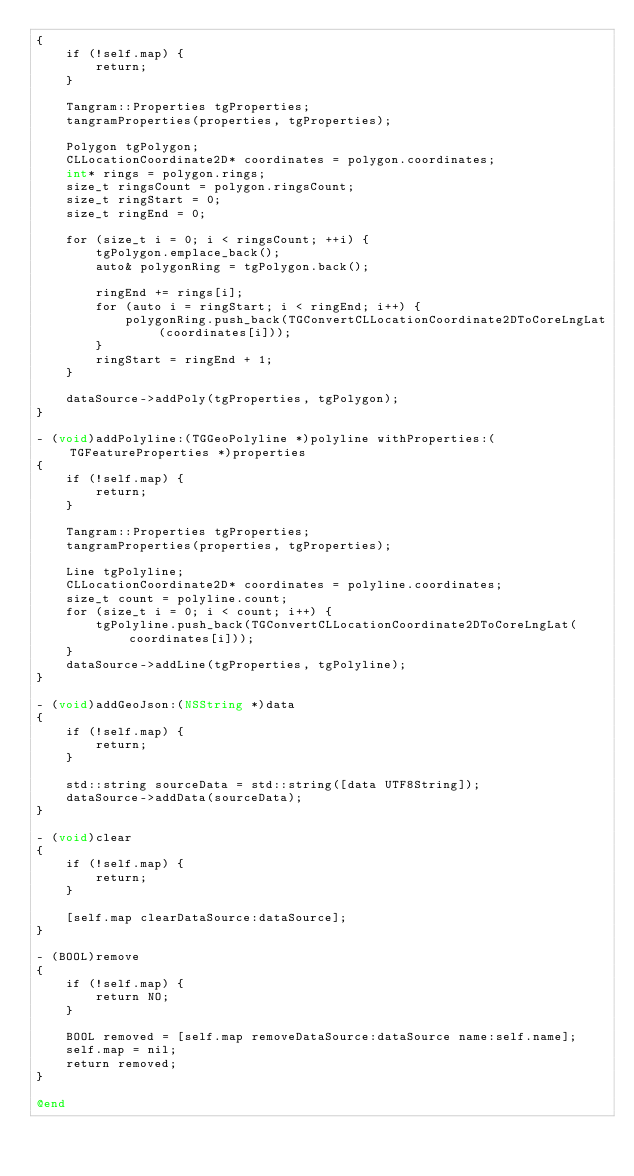<code> <loc_0><loc_0><loc_500><loc_500><_ObjectiveC_>{
    if (!self.map) {
        return;
    }

    Tangram::Properties tgProperties;
    tangramProperties(properties, tgProperties);

    Polygon tgPolygon;
    CLLocationCoordinate2D* coordinates = polygon.coordinates;
    int* rings = polygon.rings;
    size_t ringsCount = polygon.ringsCount;
    size_t ringStart = 0;
    size_t ringEnd = 0;

    for (size_t i = 0; i < ringsCount; ++i) {
        tgPolygon.emplace_back();
        auto& polygonRing = tgPolygon.back();

        ringEnd += rings[i];
        for (auto i = ringStart; i < ringEnd; i++) {
            polygonRing.push_back(TGConvertCLLocationCoordinate2DToCoreLngLat(coordinates[i]));
        }
        ringStart = ringEnd + 1;
    }

    dataSource->addPoly(tgProperties, tgPolygon);
}

- (void)addPolyline:(TGGeoPolyline *)polyline withProperties:(TGFeatureProperties *)properties
{
    if (!self.map) {
        return;
    }

    Tangram::Properties tgProperties;
    tangramProperties(properties, tgProperties);

    Line tgPolyline;
    CLLocationCoordinate2D* coordinates = polyline.coordinates;
    size_t count = polyline.count;
    for (size_t i = 0; i < count; i++) {
        tgPolyline.push_back(TGConvertCLLocationCoordinate2DToCoreLngLat(coordinates[i]));
    }
    dataSource->addLine(tgProperties, tgPolyline);
}

- (void)addGeoJson:(NSString *)data
{
    if (!self.map) {
        return;
    }

    std::string sourceData = std::string([data UTF8String]);
    dataSource->addData(sourceData);
}

- (void)clear
{
    if (!self.map) {
        return;
    }

    [self.map clearDataSource:dataSource];
}

- (BOOL)remove
{
    if (!self.map) {
        return NO;
    }

    BOOL removed = [self.map removeDataSource:dataSource name:self.name];
    self.map = nil;
    return removed;
}

@end
</code> 